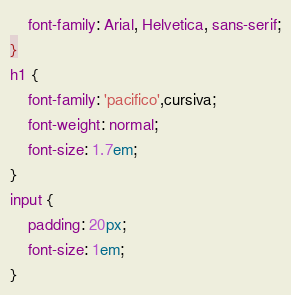<code> <loc_0><loc_0><loc_500><loc_500><_CSS_>    font-family: Arial, Helvetica, sans-serif;
}
h1 {
    font-family: 'pacifico',cursiva;
    font-weight: normal;
    font-size: 1.7em;
}
input {
    padding: 20px;
    font-size: 1em;
}</code> 